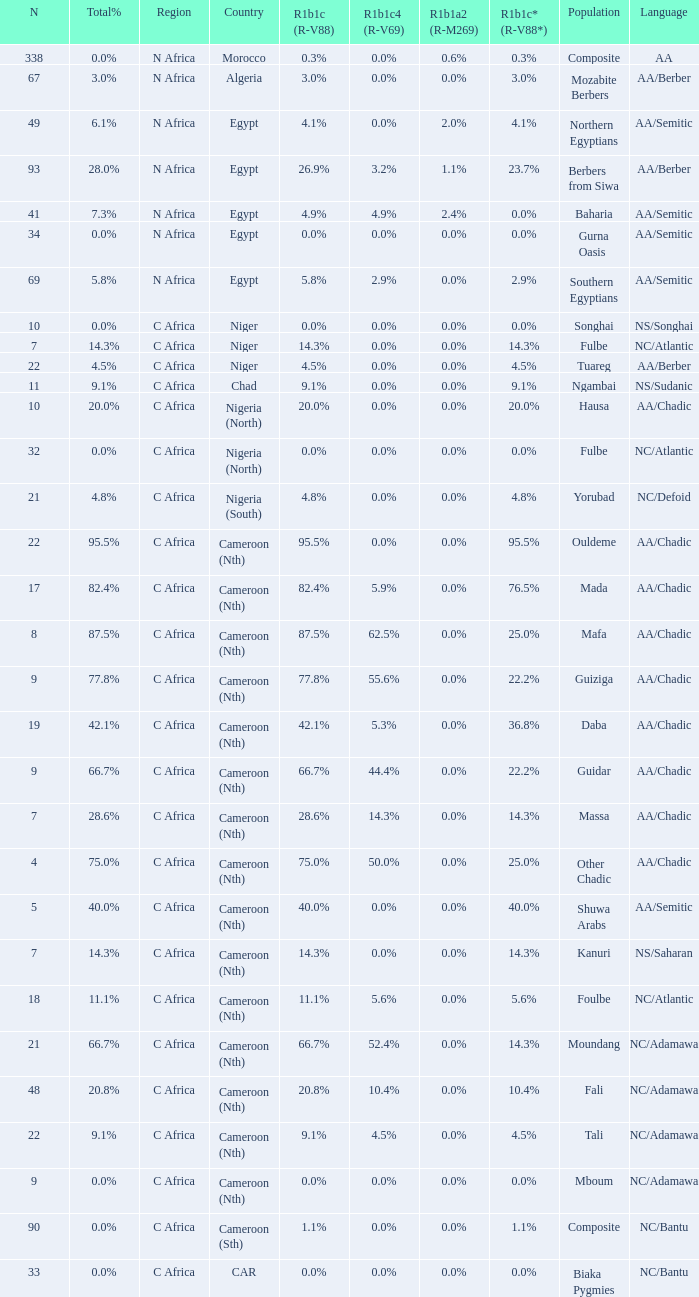How many n are listed for 0.6% r1b1a2 (r-m269)? 1.0. 